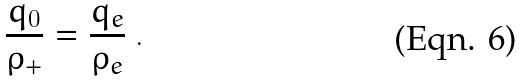<formula> <loc_0><loc_0><loc_500><loc_500>\frac { q _ { 0 } } { \rho _ { + } } = \frac { q _ { e } } { \rho _ { e } } \ .</formula> 